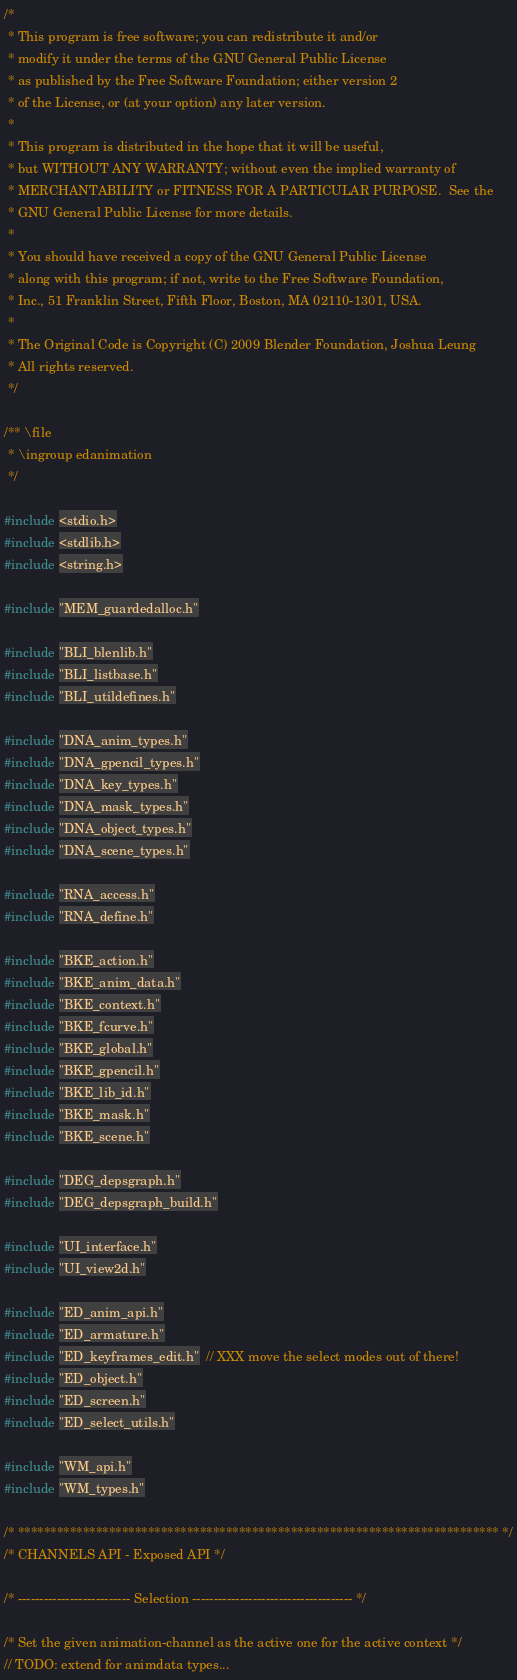<code> <loc_0><loc_0><loc_500><loc_500><_C_>/*
 * This program is free software; you can redistribute it and/or
 * modify it under the terms of the GNU General Public License
 * as published by the Free Software Foundation; either version 2
 * of the License, or (at your option) any later version.
 *
 * This program is distributed in the hope that it will be useful,
 * but WITHOUT ANY WARRANTY; without even the implied warranty of
 * MERCHANTABILITY or FITNESS FOR A PARTICULAR PURPOSE.  See the
 * GNU General Public License for more details.
 *
 * You should have received a copy of the GNU General Public License
 * along with this program; if not, write to the Free Software Foundation,
 * Inc., 51 Franklin Street, Fifth Floor, Boston, MA 02110-1301, USA.
 *
 * The Original Code is Copyright (C) 2009 Blender Foundation, Joshua Leung
 * All rights reserved.
 */

/** \file
 * \ingroup edanimation
 */

#include <stdio.h>
#include <stdlib.h>
#include <string.h>

#include "MEM_guardedalloc.h"

#include "BLI_blenlib.h"
#include "BLI_listbase.h"
#include "BLI_utildefines.h"

#include "DNA_anim_types.h"
#include "DNA_gpencil_types.h"
#include "DNA_key_types.h"
#include "DNA_mask_types.h"
#include "DNA_object_types.h"
#include "DNA_scene_types.h"

#include "RNA_access.h"
#include "RNA_define.h"

#include "BKE_action.h"
#include "BKE_anim_data.h"
#include "BKE_context.h"
#include "BKE_fcurve.h"
#include "BKE_global.h"
#include "BKE_gpencil.h"
#include "BKE_lib_id.h"
#include "BKE_mask.h"
#include "BKE_scene.h"

#include "DEG_depsgraph.h"
#include "DEG_depsgraph_build.h"

#include "UI_interface.h"
#include "UI_view2d.h"

#include "ED_anim_api.h"
#include "ED_armature.h"
#include "ED_keyframes_edit.h"  // XXX move the select modes out of there!
#include "ED_object.h"
#include "ED_screen.h"
#include "ED_select_utils.h"

#include "WM_api.h"
#include "WM_types.h"

/* ************************************************************************** */
/* CHANNELS API - Exposed API */

/* -------------------------- Selection ------------------------------------- */

/* Set the given animation-channel as the active one for the active context */
// TODO: extend for animdata types...</code> 